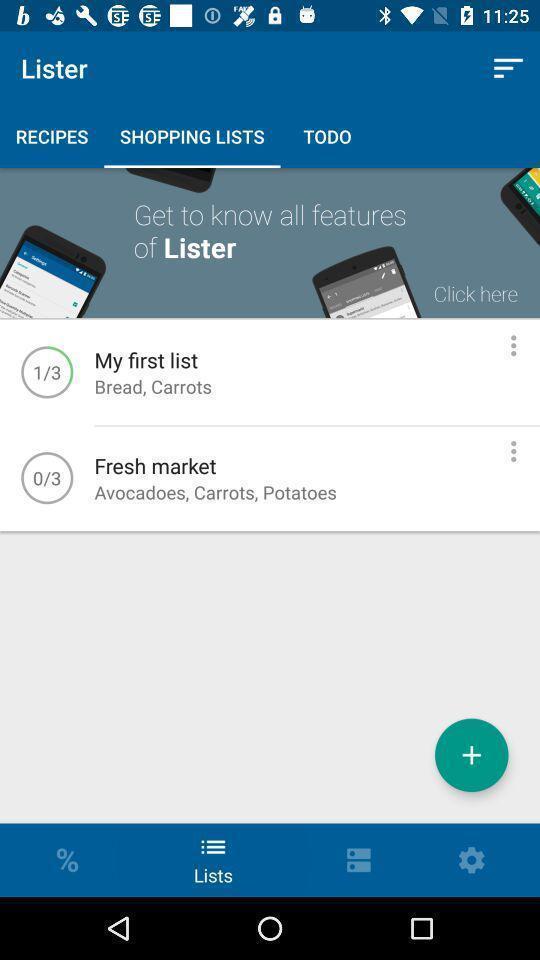Provide a textual representation of this image. Screen displaying shopping lists page. 